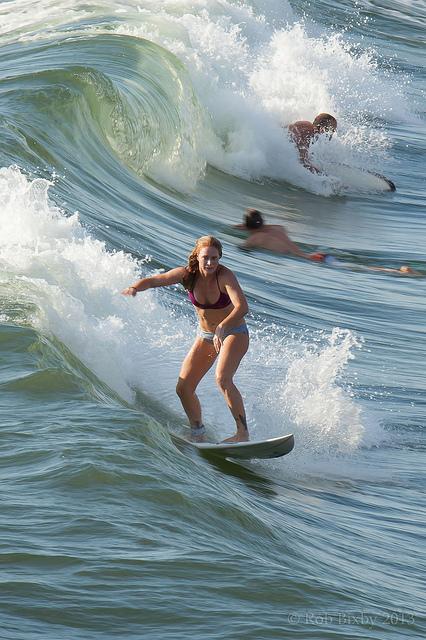Is the woman wearing a bikini?
Concise answer only. Yes. What are they doing?
Give a very brief answer. Surfing. They are surfing?
Quick response, please. Yes. 